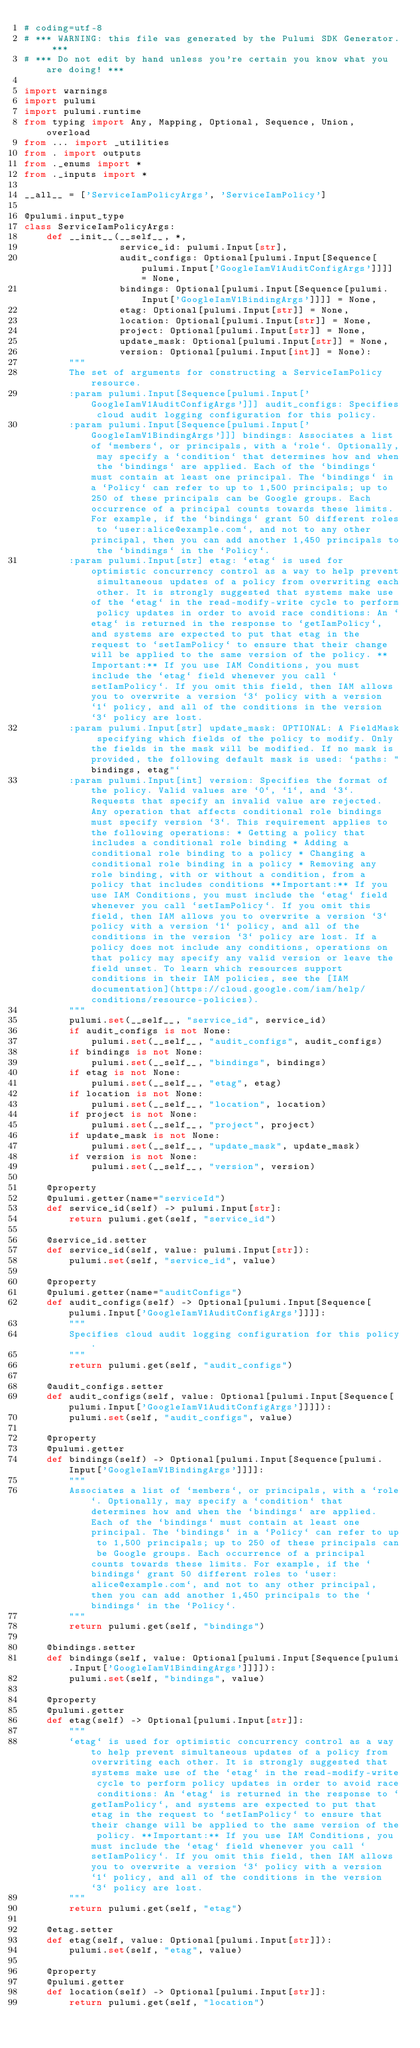<code> <loc_0><loc_0><loc_500><loc_500><_Python_># coding=utf-8
# *** WARNING: this file was generated by the Pulumi SDK Generator. ***
# *** Do not edit by hand unless you're certain you know what you are doing! ***

import warnings
import pulumi
import pulumi.runtime
from typing import Any, Mapping, Optional, Sequence, Union, overload
from ... import _utilities
from . import outputs
from ._enums import *
from ._inputs import *

__all__ = ['ServiceIamPolicyArgs', 'ServiceIamPolicy']

@pulumi.input_type
class ServiceIamPolicyArgs:
    def __init__(__self__, *,
                 service_id: pulumi.Input[str],
                 audit_configs: Optional[pulumi.Input[Sequence[pulumi.Input['GoogleIamV1AuditConfigArgs']]]] = None,
                 bindings: Optional[pulumi.Input[Sequence[pulumi.Input['GoogleIamV1BindingArgs']]]] = None,
                 etag: Optional[pulumi.Input[str]] = None,
                 location: Optional[pulumi.Input[str]] = None,
                 project: Optional[pulumi.Input[str]] = None,
                 update_mask: Optional[pulumi.Input[str]] = None,
                 version: Optional[pulumi.Input[int]] = None):
        """
        The set of arguments for constructing a ServiceIamPolicy resource.
        :param pulumi.Input[Sequence[pulumi.Input['GoogleIamV1AuditConfigArgs']]] audit_configs: Specifies cloud audit logging configuration for this policy.
        :param pulumi.Input[Sequence[pulumi.Input['GoogleIamV1BindingArgs']]] bindings: Associates a list of `members`, or principals, with a `role`. Optionally, may specify a `condition` that determines how and when the `bindings` are applied. Each of the `bindings` must contain at least one principal. The `bindings` in a `Policy` can refer to up to 1,500 principals; up to 250 of these principals can be Google groups. Each occurrence of a principal counts towards these limits. For example, if the `bindings` grant 50 different roles to `user:alice@example.com`, and not to any other principal, then you can add another 1,450 principals to the `bindings` in the `Policy`.
        :param pulumi.Input[str] etag: `etag` is used for optimistic concurrency control as a way to help prevent simultaneous updates of a policy from overwriting each other. It is strongly suggested that systems make use of the `etag` in the read-modify-write cycle to perform policy updates in order to avoid race conditions: An `etag` is returned in the response to `getIamPolicy`, and systems are expected to put that etag in the request to `setIamPolicy` to ensure that their change will be applied to the same version of the policy. **Important:** If you use IAM Conditions, you must include the `etag` field whenever you call `setIamPolicy`. If you omit this field, then IAM allows you to overwrite a version `3` policy with a version `1` policy, and all of the conditions in the version `3` policy are lost.
        :param pulumi.Input[str] update_mask: OPTIONAL: A FieldMask specifying which fields of the policy to modify. Only the fields in the mask will be modified. If no mask is provided, the following default mask is used: `paths: "bindings, etag"`
        :param pulumi.Input[int] version: Specifies the format of the policy. Valid values are `0`, `1`, and `3`. Requests that specify an invalid value are rejected. Any operation that affects conditional role bindings must specify version `3`. This requirement applies to the following operations: * Getting a policy that includes a conditional role binding * Adding a conditional role binding to a policy * Changing a conditional role binding in a policy * Removing any role binding, with or without a condition, from a policy that includes conditions **Important:** If you use IAM Conditions, you must include the `etag` field whenever you call `setIamPolicy`. If you omit this field, then IAM allows you to overwrite a version `3` policy with a version `1` policy, and all of the conditions in the version `3` policy are lost. If a policy does not include any conditions, operations on that policy may specify any valid version or leave the field unset. To learn which resources support conditions in their IAM policies, see the [IAM documentation](https://cloud.google.com/iam/help/conditions/resource-policies).
        """
        pulumi.set(__self__, "service_id", service_id)
        if audit_configs is not None:
            pulumi.set(__self__, "audit_configs", audit_configs)
        if bindings is not None:
            pulumi.set(__self__, "bindings", bindings)
        if etag is not None:
            pulumi.set(__self__, "etag", etag)
        if location is not None:
            pulumi.set(__self__, "location", location)
        if project is not None:
            pulumi.set(__self__, "project", project)
        if update_mask is not None:
            pulumi.set(__self__, "update_mask", update_mask)
        if version is not None:
            pulumi.set(__self__, "version", version)

    @property
    @pulumi.getter(name="serviceId")
    def service_id(self) -> pulumi.Input[str]:
        return pulumi.get(self, "service_id")

    @service_id.setter
    def service_id(self, value: pulumi.Input[str]):
        pulumi.set(self, "service_id", value)

    @property
    @pulumi.getter(name="auditConfigs")
    def audit_configs(self) -> Optional[pulumi.Input[Sequence[pulumi.Input['GoogleIamV1AuditConfigArgs']]]]:
        """
        Specifies cloud audit logging configuration for this policy.
        """
        return pulumi.get(self, "audit_configs")

    @audit_configs.setter
    def audit_configs(self, value: Optional[pulumi.Input[Sequence[pulumi.Input['GoogleIamV1AuditConfigArgs']]]]):
        pulumi.set(self, "audit_configs", value)

    @property
    @pulumi.getter
    def bindings(self) -> Optional[pulumi.Input[Sequence[pulumi.Input['GoogleIamV1BindingArgs']]]]:
        """
        Associates a list of `members`, or principals, with a `role`. Optionally, may specify a `condition` that determines how and when the `bindings` are applied. Each of the `bindings` must contain at least one principal. The `bindings` in a `Policy` can refer to up to 1,500 principals; up to 250 of these principals can be Google groups. Each occurrence of a principal counts towards these limits. For example, if the `bindings` grant 50 different roles to `user:alice@example.com`, and not to any other principal, then you can add another 1,450 principals to the `bindings` in the `Policy`.
        """
        return pulumi.get(self, "bindings")

    @bindings.setter
    def bindings(self, value: Optional[pulumi.Input[Sequence[pulumi.Input['GoogleIamV1BindingArgs']]]]):
        pulumi.set(self, "bindings", value)

    @property
    @pulumi.getter
    def etag(self) -> Optional[pulumi.Input[str]]:
        """
        `etag` is used for optimistic concurrency control as a way to help prevent simultaneous updates of a policy from overwriting each other. It is strongly suggested that systems make use of the `etag` in the read-modify-write cycle to perform policy updates in order to avoid race conditions: An `etag` is returned in the response to `getIamPolicy`, and systems are expected to put that etag in the request to `setIamPolicy` to ensure that their change will be applied to the same version of the policy. **Important:** If you use IAM Conditions, you must include the `etag` field whenever you call `setIamPolicy`. If you omit this field, then IAM allows you to overwrite a version `3` policy with a version `1` policy, and all of the conditions in the version `3` policy are lost.
        """
        return pulumi.get(self, "etag")

    @etag.setter
    def etag(self, value: Optional[pulumi.Input[str]]):
        pulumi.set(self, "etag", value)

    @property
    @pulumi.getter
    def location(self) -> Optional[pulumi.Input[str]]:
        return pulumi.get(self, "location")
</code> 